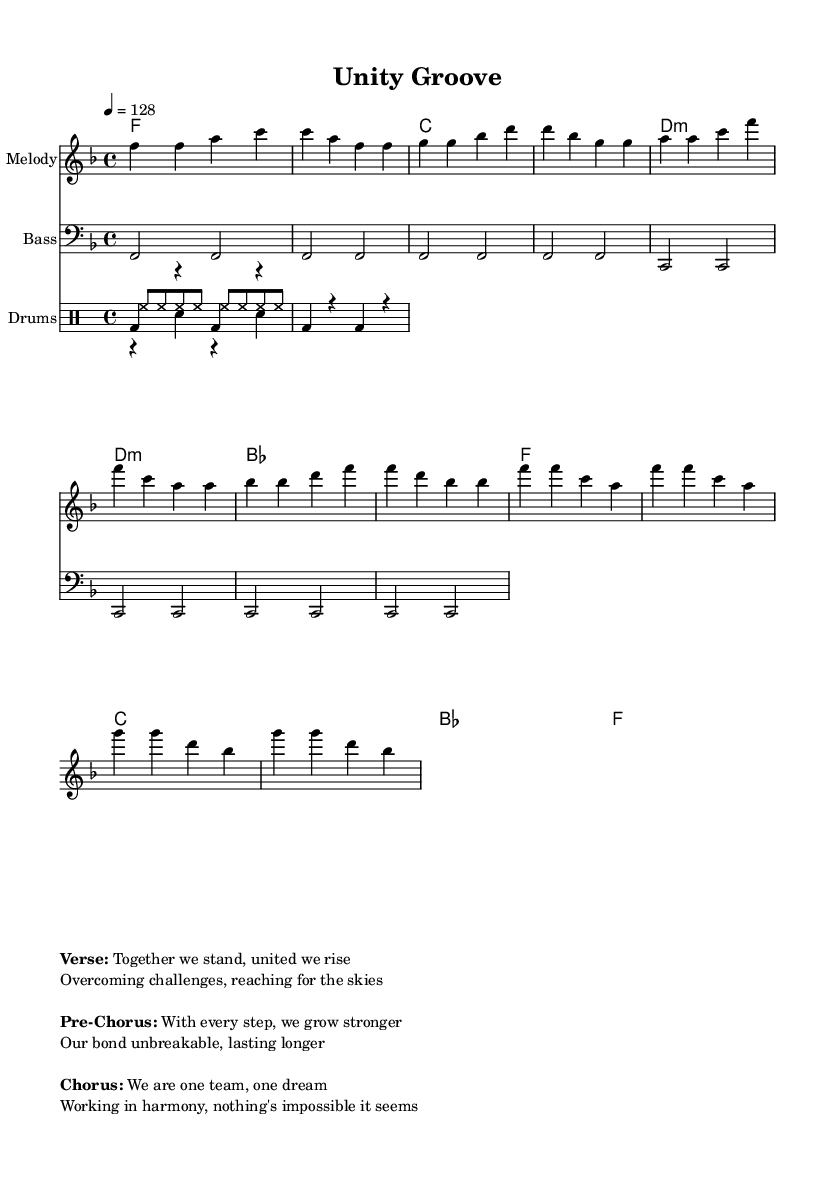What is the key signature of this music? The key signature is F major, which has one flat (B flat). This is indicated by the presence of the flat symbol at the beginning of the staff.
Answer: F major What is the time signature of this piece? The time signature is 4/4, which indicates there are four beats in each measure and the quarter note gets one beat. This is shown at the beginning of the score.
Answer: 4/4 What is the tempo marking of the music? The tempo marking is 128 beats per minute, indicated by the symbol "4 = 128." This provides the speed at which the piece should be played.
Answer: 128 How many measures are in the verse section? The verse section consists of four measures, as denoted by the sequence of four sets of rhythm in the melody and chord progressions.
Answer: Four Which chord is repeatedly played during the chorus? The chord that is repeatedly played during the chorus is F major, as identified through the chord notation in the score and its presence at the start of each measure in the chorus section.
Answer: F How does the pre-chorus' progression differ from the verse's progression? The pre-chorus features a chord progression that includes a D minor chord, while the verse primarily consists of F major and C major chords. The changes in harmony indicate a buildup to the chorus.
Answer: D minor What is the lyrical theme expressed in the chorus? The lyrical theme expressed in the chorus emphasizes unity and teamwork, indicating that together, nothing is impossible. This theme is highlighted by the lyrics "We are one team, one dream."
Answer: Unity and teamwork 